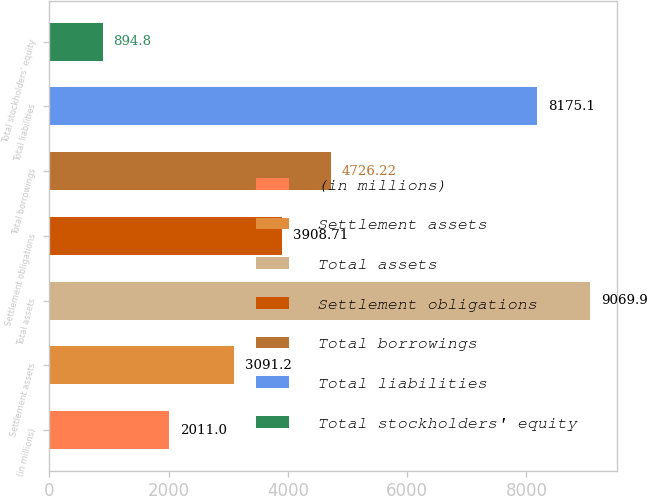Convert chart. <chart><loc_0><loc_0><loc_500><loc_500><bar_chart><fcel>(in millions)<fcel>Settlement assets<fcel>Total assets<fcel>Settlement obligations<fcel>Total borrowings<fcel>Total liabilities<fcel>Total stockholders' equity<nl><fcel>2011<fcel>3091.2<fcel>9069.9<fcel>3908.71<fcel>4726.22<fcel>8175.1<fcel>894.8<nl></chart> 